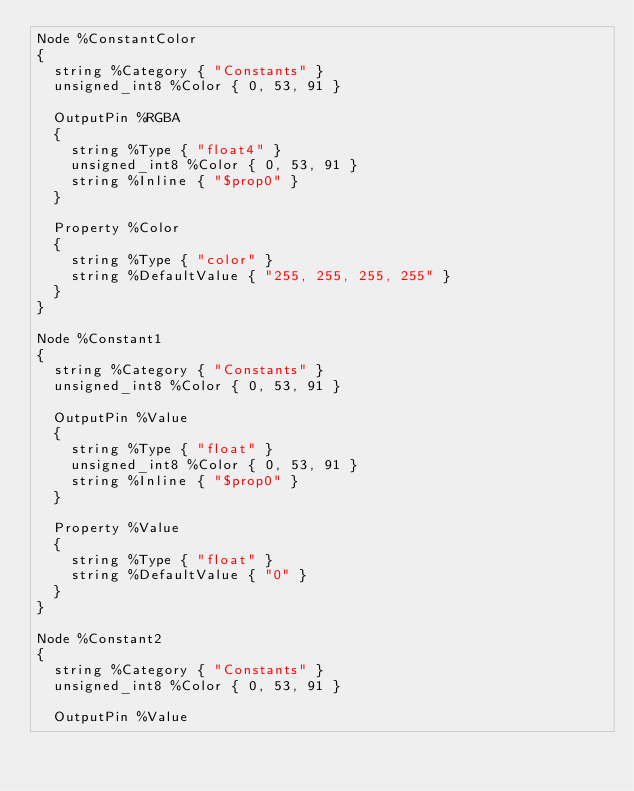<code> <loc_0><loc_0><loc_500><loc_500><_SQL_>Node %ConstantColor
{
  string %Category { "Constants" }
  unsigned_int8 %Color { 0, 53, 91 }

  OutputPin %RGBA
  {
    string %Type { "float4" }
    unsigned_int8 %Color { 0, 53, 91 }
    string %Inline { "$prop0" }
  }

  Property %Color
  {
    string %Type { "color" }
    string %DefaultValue { "255, 255, 255, 255" }
  }
}

Node %Constant1
{
  string %Category { "Constants" }
  unsigned_int8 %Color { 0, 53, 91 }

  OutputPin %Value
  {
    string %Type { "float" }
    unsigned_int8 %Color { 0, 53, 91 }
    string %Inline { "$prop0" }
  }

  Property %Value
  {
    string %Type { "float" }
    string %DefaultValue { "0" }
  }
}

Node %Constant2
{
  string %Category { "Constants" }
  unsigned_int8 %Color { 0, 53, 91 }

  OutputPin %Value</code> 